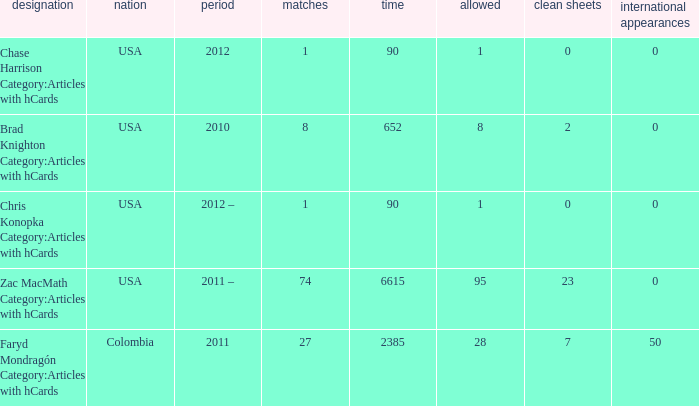When  chris konopka category:articles with hcards is the name what is the year? 2012 –. 